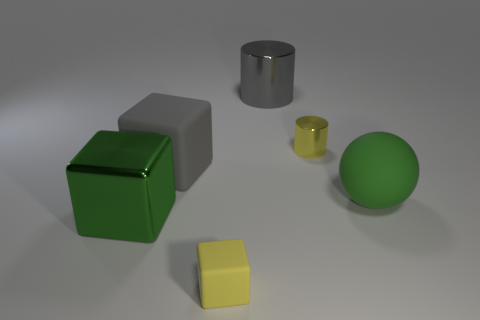What is the shape of the large rubber object that is right of the tiny rubber thing that is in front of the green matte ball?
Offer a terse response. Sphere. What color is the matte thing on the right side of the tiny cube?
Give a very brief answer. Green. There is a gray thing that is made of the same material as the large green ball; what is its size?
Provide a succinct answer. Large. The other matte object that is the same shape as the tiny yellow rubber object is what size?
Give a very brief answer. Large. Are there any gray shiny cylinders?
Your answer should be compact. Yes. How many objects are objects on the right side of the large green metallic block or small matte things?
Offer a very short reply. 5. What material is the ball that is the same size as the gray shiny thing?
Give a very brief answer. Rubber. There is a small object on the right side of the tiny thing left of the big cylinder; what is its color?
Offer a very short reply. Yellow. There is a small cylinder; how many big things are in front of it?
Make the answer very short. 3. What is the color of the big cylinder?
Your response must be concise. Gray. 